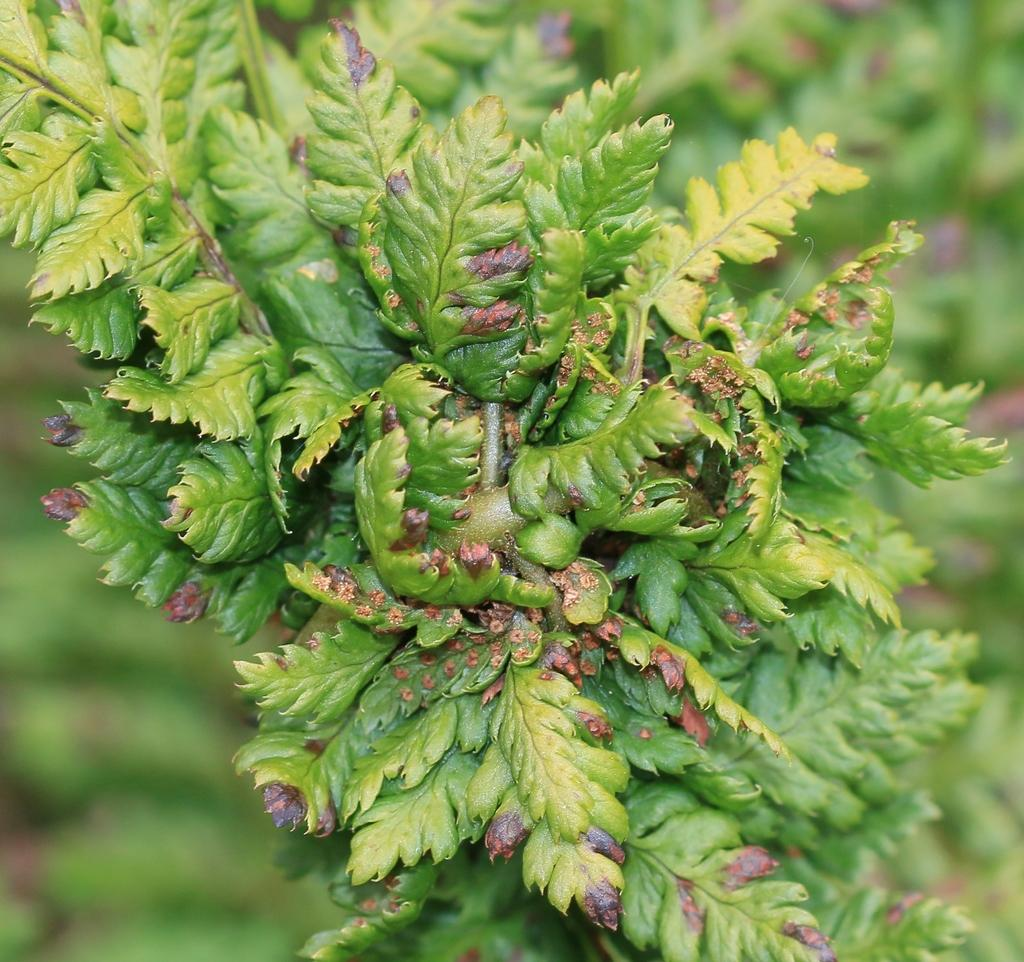What type of vegetation can be seen in the image? There are leaves in the image. Where are the leaves located in relation to the image? The leaves are in the foreground. What color is predominant in the background of the image? The background of the image is green. How would you describe the clarity of the image? The image is blurry. What type of current is flowing through the leaves in the image? There is no current flowing through the leaves in the image, as they are stationary and not in a body of water. 